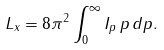<formula> <loc_0><loc_0><loc_500><loc_500>L _ { x } = 8 \pi ^ { 2 } \int _ { 0 } ^ { \infty } I _ { p } \, p \, d p .</formula> 